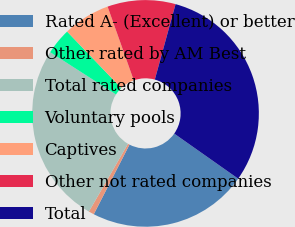Convert chart to OTSL. <chart><loc_0><loc_0><loc_500><loc_500><pie_chart><fcel>Rated A- (Excellent) or better<fcel>Other rated by AM Best<fcel>Total rated companies<fcel>Voluntary pools<fcel>Captives<fcel>Other not rated companies<fcel>Total<nl><fcel>22.78%<fcel>0.78%<fcel>25.75%<fcel>3.76%<fcel>6.73%<fcel>9.7%<fcel>30.5%<nl></chart> 